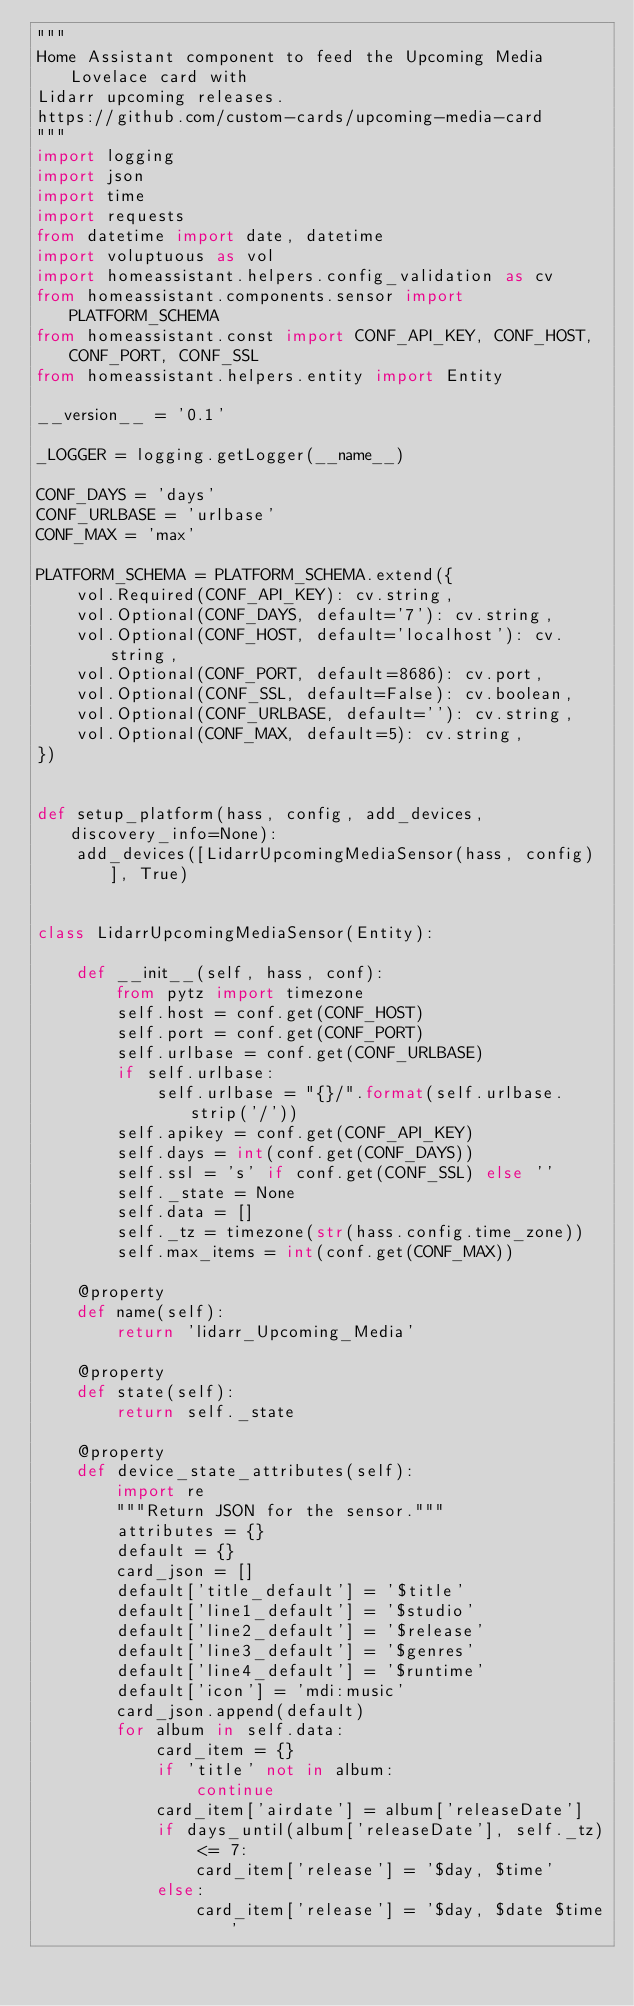Convert code to text. <code><loc_0><loc_0><loc_500><loc_500><_Python_>"""
Home Assistant component to feed the Upcoming Media Lovelace card with
Lidarr upcoming releases.
https://github.com/custom-cards/upcoming-media-card
"""
import logging
import json
import time
import requests
from datetime import date, datetime
import voluptuous as vol
import homeassistant.helpers.config_validation as cv
from homeassistant.components.sensor import PLATFORM_SCHEMA
from homeassistant.const import CONF_API_KEY, CONF_HOST, CONF_PORT, CONF_SSL
from homeassistant.helpers.entity import Entity

__version__ = '0.1'

_LOGGER = logging.getLogger(__name__)

CONF_DAYS = 'days'
CONF_URLBASE = 'urlbase'
CONF_MAX = 'max'

PLATFORM_SCHEMA = PLATFORM_SCHEMA.extend({
    vol.Required(CONF_API_KEY): cv.string,
    vol.Optional(CONF_DAYS, default='7'): cv.string,
    vol.Optional(CONF_HOST, default='localhost'): cv.string,
    vol.Optional(CONF_PORT, default=8686): cv.port,
    vol.Optional(CONF_SSL, default=False): cv.boolean,
    vol.Optional(CONF_URLBASE, default=''): cv.string,
    vol.Optional(CONF_MAX, default=5): cv.string,
})


def setup_platform(hass, config, add_devices, discovery_info=None):
    add_devices([LidarrUpcomingMediaSensor(hass, config)], True)


class LidarrUpcomingMediaSensor(Entity):

    def __init__(self, hass, conf):
        from pytz import timezone
        self.host = conf.get(CONF_HOST)
        self.port = conf.get(CONF_PORT)
        self.urlbase = conf.get(CONF_URLBASE)
        if self.urlbase:
            self.urlbase = "{}/".format(self.urlbase.strip('/'))
        self.apikey = conf.get(CONF_API_KEY)
        self.days = int(conf.get(CONF_DAYS))
        self.ssl = 's' if conf.get(CONF_SSL) else ''
        self._state = None
        self.data = []
        self._tz = timezone(str(hass.config.time_zone))
        self.max_items = int(conf.get(CONF_MAX))

    @property
    def name(self):
        return 'lidarr_Upcoming_Media'

    @property
    def state(self):
        return self._state

    @property
    def device_state_attributes(self):
        import re
        """Return JSON for the sensor."""
        attributes = {}
        default = {}
        card_json = []
        default['title_default'] = '$title'
        default['line1_default'] = '$studio'
        default['line2_default'] = '$release'
        default['line3_default'] = '$genres'
        default['line4_default'] = '$runtime'
        default['icon'] = 'mdi:music'
        card_json.append(default)
        for album in self.data:
            card_item = {}
            if 'title' not in album:
                continue
            card_item['airdate'] = album['releaseDate']
            if days_until(album['releaseDate'], self._tz) <= 7:
                card_item['release'] = '$day, $time'
            else:
                card_item['release'] = '$day, $date $time'
            </code> 